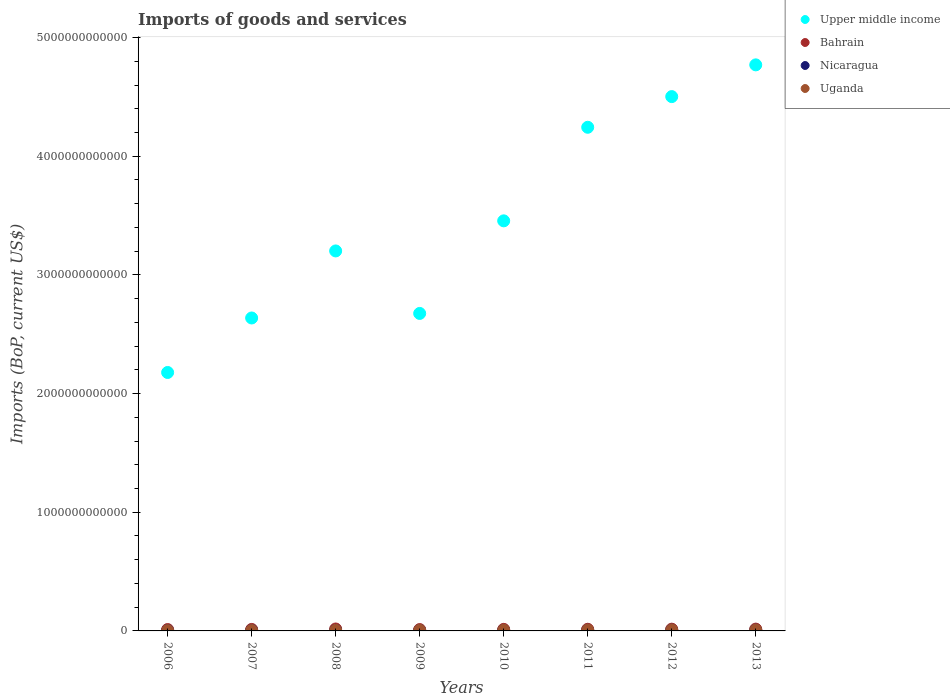How many different coloured dotlines are there?
Make the answer very short. 4. What is the amount spent on imports in Bahrain in 2010?
Keep it short and to the point. 1.31e+1. Across all years, what is the maximum amount spent on imports in Upper middle income?
Give a very brief answer. 4.77e+12. Across all years, what is the minimum amount spent on imports in Uganda?
Make the answer very short. 2.99e+09. In which year was the amount spent on imports in Bahrain maximum?
Your response must be concise. 2008. What is the total amount spent on imports in Upper middle income in the graph?
Your answer should be very brief. 2.77e+13. What is the difference between the amount spent on imports in Nicaragua in 2006 and that in 2010?
Offer a terse response. -1.38e+09. What is the difference between the amount spent on imports in Bahrain in 2009 and the amount spent on imports in Uganda in 2007?
Provide a short and direct response. 7.42e+09. What is the average amount spent on imports in Uganda per year?
Offer a very short reply. 5.80e+09. In the year 2011, what is the difference between the amount spent on imports in Upper middle income and amount spent on imports in Nicaragua?
Your answer should be compact. 4.24e+12. In how many years, is the amount spent on imports in Upper middle income greater than 3200000000000 US$?
Offer a very short reply. 5. What is the ratio of the amount spent on imports in Upper middle income in 2008 to that in 2013?
Keep it short and to the point. 0.67. Is the amount spent on imports in Nicaragua in 2007 less than that in 2010?
Keep it short and to the point. Yes. Is the difference between the amount spent on imports in Upper middle income in 2008 and 2011 greater than the difference between the amount spent on imports in Nicaragua in 2008 and 2011?
Keep it short and to the point. No. What is the difference between the highest and the second highest amount spent on imports in Uganda?
Make the answer very short. 9.31e+07. What is the difference between the highest and the lowest amount spent on imports in Nicaragua?
Offer a terse response. 3.19e+09. Does the amount spent on imports in Bahrain monotonically increase over the years?
Provide a succinct answer. No. Is the amount spent on imports in Bahrain strictly greater than the amount spent on imports in Nicaragua over the years?
Your answer should be compact. Yes. Is the amount spent on imports in Nicaragua strictly less than the amount spent on imports in Uganda over the years?
Provide a short and direct response. No. How many dotlines are there?
Your response must be concise. 4. How many years are there in the graph?
Make the answer very short. 8. What is the difference between two consecutive major ticks on the Y-axis?
Your response must be concise. 1.00e+12. Where does the legend appear in the graph?
Offer a very short reply. Top right. How many legend labels are there?
Make the answer very short. 4. How are the legend labels stacked?
Provide a short and direct response. Vertical. What is the title of the graph?
Your response must be concise. Imports of goods and services. What is the label or title of the X-axis?
Keep it short and to the point. Years. What is the label or title of the Y-axis?
Provide a short and direct response. Imports (BoP, current US$). What is the Imports (BoP, current US$) of Upper middle income in 2006?
Offer a very short reply. 2.18e+12. What is the Imports (BoP, current US$) of Bahrain in 2006?
Your response must be concise. 1.16e+1. What is the Imports (BoP, current US$) of Nicaragua in 2006?
Offer a very short reply. 3.68e+09. What is the Imports (BoP, current US$) in Uganda in 2006?
Keep it short and to the point. 2.99e+09. What is the Imports (BoP, current US$) in Upper middle income in 2007?
Provide a short and direct response. 2.64e+12. What is the Imports (BoP, current US$) of Bahrain in 2007?
Offer a terse response. 1.26e+1. What is the Imports (BoP, current US$) of Nicaragua in 2007?
Give a very brief answer. 4.45e+09. What is the Imports (BoP, current US$) in Uganda in 2007?
Your response must be concise. 3.94e+09. What is the Imports (BoP, current US$) in Upper middle income in 2008?
Provide a short and direct response. 3.20e+12. What is the Imports (BoP, current US$) of Bahrain in 2008?
Provide a succinct answer. 1.63e+1. What is the Imports (BoP, current US$) of Nicaragua in 2008?
Your response must be concise. 5.26e+09. What is the Imports (BoP, current US$) of Uganda in 2008?
Keep it short and to the point. 5.30e+09. What is the Imports (BoP, current US$) in Upper middle income in 2009?
Offer a terse response. 2.68e+12. What is the Imports (BoP, current US$) in Bahrain in 2009?
Provide a succinct answer. 1.14e+1. What is the Imports (BoP, current US$) of Nicaragua in 2009?
Provide a short and direct response. 4.41e+09. What is the Imports (BoP, current US$) in Uganda in 2009?
Offer a very short reply. 5.23e+09. What is the Imports (BoP, current US$) of Upper middle income in 2010?
Your response must be concise. 3.46e+12. What is the Imports (BoP, current US$) of Bahrain in 2010?
Offer a very short reply. 1.31e+1. What is the Imports (BoP, current US$) in Nicaragua in 2010?
Make the answer very short. 5.06e+09. What is the Imports (BoP, current US$) in Uganda in 2010?
Ensure brevity in your answer.  6.18e+09. What is the Imports (BoP, current US$) in Upper middle income in 2011?
Keep it short and to the point. 4.24e+12. What is the Imports (BoP, current US$) in Bahrain in 2011?
Your response must be concise. 1.39e+1. What is the Imports (BoP, current US$) in Nicaragua in 2011?
Give a very brief answer. 6.30e+09. What is the Imports (BoP, current US$) in Uganda in 2011?
Provide a succinct answer. 7.43e+09. What is the Imports (BoP, current US$) in Upper middle income in 2012?
Make the answer very short. 4.50e+12. What is the Imports (BoP, current US$) of Bahrain in 2012?
Give a very brief answer. 1.47e+1. What is the Imports (BoP, current US$) in Nicaragua in 2012?
Keep it short and to the point. 6.84e+09. What is the Imports (BoP, current US$) of Uganda in 2012?
Offer a terse response. 7.74e+09. What is the Imports (BoP, current US$) in Upper middle income in 2013?
Your response must be concise. 4.77e+12. What is the Imports (BoP, current US$) in Bahrain in 2013?
Provide a succinct answer. 1.52e+1. What is the Imports (BoP, current US$) of Nicaragua in 2013?
Make the answer very short. 6.87e+09. What is the Imports (BoP, current US$) of Uganda in 2013?
Your answer should be compact. 7.64e+09. Across all years, what is the maximum Imports (BoP, current US$) of Upper middle income?
Keep it short and to the point. 4.77e+12. Across all years, what is the maximum Imports (BoP, current US$) in Bahrain?
Offer a very short reply. 1.63e+1. Across all years, what is the maximum Imports (BoP, current US$) of Nicaragua?
Your response must be concise. 6.87e+09. Across all years, what is the maximum Imports (BoP, current US$) in Uganda?
Make the answer very short. 7.74e+09. Across all years, what is the minimum Imports (BoP, current US$) in Upper middle income?
Keep it short and to the point. 2.18e+12. Across all years, what is the minimum Imports (BoP, current US$) of Bahrain?
Give a very brief answer. 1.14e+1. Across all years, what is the minimum Imports (BoP, current US$) of Nicaragua?
Give a very brief answer. 3.68e+09. Across all years, what is the minimum Imports (BoP, current US$) in Uganda?
Make the answer very short. 2.99e+09. What is the total Imports (BoP, current US$) in Upper middle income in the graph?
Provide a succinct answer. 2.77e+13. What is the total Imports (BoP, current US$) of Bahrain in the graph?
Ensure brevity in your answer.  1.09e+11. What is the total Imports (BoP, current US$) of Nicaragua in the graph?
Give a very brief answer. 4.29e+1. What is the total Imports (BoP, current US$) of Uganda in the graph?
Ensure brevity in your answer.  4.64e+1. What is the difference between the Imports (BoP, current US$) in Upper middle income in 2006 and that in 2007?
Your answer should be compact. -4.59e+11. What is the difference between the Imports (BoP, current US$) of Bahrain in 2006 and that in 2007?
Offer a very short reply. -1.07e+09. What is the difference between the Imports (BoP, current US$) in Nicaragua in 2006 and that in 2007?
Make the answer very short. -7.70e+08. What is the difference between the Imports (BoP, current US$) of Uganda in 2006 and that in 2007?
Your answer should be very brief. -9.49e+08. What is the difference between the Imports (BoP, current US$) of Upper middle income in 2006 and that in 2008?
Provide a short and direct response. -1.02e+12. What is the difference between the Imports (BoP, current US$) in Bahrain in 2006 and that in 2008?
Make the answer very short. -4.72e+09. What is the difference between the Imports (BoP, current US$) in Nicaragua in 2006 and that in 2008?
Provide a short and direct response. -1.57e+09. What is the difference between the Imports (BoP, current US$) of Uganda in 2006 and that in 2008?
Offer a terse response. -2.31e+09. What is the difference between the Imports (BoP, current US$) in Upper middle income in 2006 and that in 2009?
Give a very brief answer. -4.98e+11. What is the difference between the Imports (BoP, current US$) of Bahrain in 2006 and that in 2009?
Make the answer very short. 2.05e+08. What is the difference between the Imports (BoP, current US$) of Nicaragua in 2006 and that in 2009?
Your response must be concise. -7.30e+08. What is the difference between the Imports (BoP, current US$) of Uganda in 2006 and that in 2009?
Offer a terse response. -2.24e+09. What is the difference between the Imports (BoP, current US$) in Upper middle income in 2006 and that in 2010?
Provide a succinct answer. -1.28e+12. What is the difference between the Imports (BoP, current US$) in Bahrain in 2006 and that in 2010?
Your answer should be very brief. -1.54e+09. What is the difference between the Imports (BoP, current US$) of Nicaragua in 2006 and that in 2010?
Your answer should be compact. -1.38e+09. What is the difference between the Imports (BoP, current US$) in Uganda in 2006 and that in 2010?
Your answer should be compact. -3.19e+09. What is the difference between the Imports (BoP, current US$) of Upper middle income in 2006 and that in 2011?
Make the answer very short. -2.07e+12. What is the difference between the Imports (BoP, current US$) in Bahrain in 2006 and that in 2011?
Give a very brief answer. -2.33e+09. What is the difference between the Imports (BoP, current US$) in Nicaragua in 2006 and that in 2011?
Ensure brevity in your answer.  -2.62e+09. What is the difference between the Imports (BoP, current US$) in Uganda in 2006 and that in 2011?
Offer a terse response. -4.44e+09. What is the difference between the Imports (BoP, current US$) in Upper middle income in 2006 and that in 2012?
Keep it short and to the point. -2.32e+12. What is the difference between the Imports (BoP, current US$) in Bahrain in 2006 and that in 2012?
Your answer should be very brief. -3.16e+09. What is the difference between the Imports (BoP, current US$) in Nicaragua in 2006 and that in 2012?
Your answer should be very brief. -3.16e+09. What is the difference between the Imports (BoP, current US$) of Uganda in 2006 and that in 2012?
Your response must be concise. -4.75e+09. What is the difference between the Imports (BoP, current US$) of Upper middle income in 2006 and that in 2013?
Give a very brief answer. -2.59e+12. What is the difference between the Imports (BoP, current US$) of Bahrain in 2006 and that in 2013?
Your answer should be very brief. -3.66e+09. What is the difference between the Imports (BoP, current US$) in Nicaragua in 2006 and that in 2013?
Your answer should be very brief. -3.19e+09. What is the difference between the Imports (BoP, current US$) in Uganda in 2006 and that in 2013?
Make the answer very short. -4.66e+09. What is the difference between the Imports (BoP, current US$) in Upper middle income in 2007 and that in 2008?
Ensure brevity in your answer.  -5.65e+11. What is the difference between the Imports (BoP, current US$) of Bahrain in 2007 and that in 2008?
Keep it short and to the point. -3.65e+09. What is the difference between the Imports (BoP, current US$) in Nicaragua in 2007 and that in 2008?
Your answer should be compact. -8.05e+08. What is the difference between the Imports (BoP, current US$) of Uganda in 2007 and that in 2008?
Keep it short and to the point. -1.36e+09. What is the difference between the Imports (BoP, current US$) in Upper middle income in 2007 and that in 2009?
Give a very brief answer. -3.83e+1. What is the difference between the Imports (BoP, current US$) in Bahrain in 2007 and that in 2009?
Make the answer very short. 1.27e+09. What is the difference between the Imports (BoP, current US$) of Nicaragua in 2007 and that in 2009?
Make the answer very short. 3.97e+07. What is the difference between the Imports (BoP, current US$) in Uganda in 2007 and that in 2009?
Provide a short and direct response. -1.29e+09. What is the difference between the Imports (BoP, current US$) of Upper middle income in 2007 and that in 2010?
Your response must be concise. -8.19e+11. What is the difference between the Imports (BoP, current US$) in Bahrain in 2007 and that in 2010?
Your answer should be very brief. -4.69e+08. What is the difference between the Imports (BoP, current US$) of Nicaragua in 2007 and that in 2010?
Provide a succinct answer. -6.12e+08. What is the difference between the Imports (BoP, current US$) of Uganda in 2007 and that in 2010?
Offer a terse response. -2.24e+09. What is the difference between the Imports (BoP, current US$) of Upper middle income in 2007 and that in 2011?
Provide a succinct answer. -1.61e+12. What is the difference between the Imports (BoP, current US$) in Bahrain in 2007 and that in 2011?
Provide a short and direct response. -1.26e+09. What is the difference between the Imports (BoP, current US$) of Nicaragua in 2007 and that in 2011?
Provide a succinct answer. -1.85e+09. What is the difference between the Imports (BoP, current US$) in Uganda in 2007 and that in 2011?
Ensure brevity in your answer.  -3.49e+09. What is the difference between the Imports (BoP, current US$) in Upper middle income in 2007 and that in 2012?
Give a very brief answer. -1.87e+12. What is the difference between the Imports (BoP, current US$) in Bahrain in 2007 and that in 2012?
Offer a very short reply. -2.09e+09. What is the difference between the Imports (BoP, current US$) of Nicaragua in 2007 and that in 2012?
Your answer should be very brief. -2.39e+09. What is the difference between the Imports (BoP, current US$) in Uganda in 2007 and that in 2012?
Give a very brief answer. -3.80e+09. What is the difference between the Imports (BoP, current US$) in Upper middle income in 2007 and that in 2013?
Your answer should be very brief. -2.13e+12. What is the difference between the Imports (BoP, current US$) of Bahrain in 2007 and that in 2013?
Your response must be concise. -2.59e+09. What is the difference between the Imports (BoP, current US$) of Nicaragua in 2007 and that in 2013?
Make the answer very short. -2.42e+09. What is the difference between the Imports (BoP, current US$) of Uganda in 2007 and that in 2013?
Offer a terse response. -3.71e+09. What is the difference between the Imports (BoP, current US$) in Upper middle income in 2008 and that in 2009?
Provide a short and direct response. 5.27e+11. What is the difference between the Imports (BoP, current US$) of Bahrain in 2008 and that in 2009?
Your answer should be compact. 4.92e+09. What is the difference between the Imports (BoP, current US$) of Nicaragua in 2008 and that in 2009?
Offer a terse response. 8.44e+08. What is the difference between the Imports (BoP, current US$) in Uganda in 2008 and that in 2009?
Ensure brevity in your answer.  7.20e+07. What is the difference between the Imports (BoP, current US$) in Upper middle income in 2008 and that in 2010?
Your answer should be very brief. -2.54e+11. What is the difference between the Imports (BoP, current US$) of Bahrain in 2008 and that in 2010?
Make the answer very short. 3.18e+09. What is the difference between the Imports (BoP, current US$) of Nicaragua in 2008 and that in 2010?
Your answer should be very brief. 1.92e+08. What is the difference between the Imports (BoP, current US$) in Uganda in 2008 and that in 2010?
Provide a short and direct response. -8.78e+08. What is the difference between the Imports (BoP, current US$) of Upper middle income in 2008 and that in 2011?
Provide a short and direct response. -1.04e+12. What is the difference between the Imports (BoP, current US$) of Bahrain in 2008 and that in 2011?
Give a very brief answer. 2.39e+09. What is the difference between the Imports (BoP, current US$) of Nicaragua in 2008 and that in 2011?
Offer a very short reply. -1.05e+09. What is the difference between the Imports (BoP, current US$) in Uganda in 2008 and that in 2011?
Ensure brevity in your answer.  -2.13e+09. What is the difference between the Imports (BoP, current US$) in Upper middle income in 2008 and that in 2012?
Provide a short and direct response. -1.30e+12. What is the difference between the Imports (BoP, current US$) of Bahrain in 2008 and that in 2012?
Your response must be concise. 1.56e+09. What is the difference between the Imports (BoP, current US$) in Nicaragua in 2008 and that in 2012?
Provide a succinct answer. -1.58e+09. What is the difference between the Imports (BoP, current US$) in Uganda in 2008 and that in 2012?
Offer a terse response. -2.44e+09. What is the difference between the Imports (BoP, current US$) of Upper middle income in 2008 and that in 2013?
Your answer should be very brief. -1.57e+12. What is the difference between the Imports (BoP, current US$) in Bahrain in 2008 and that in 2013?
Your answer should be compact. 1.06e+09. What is the difference between the Imports (BoP, current US$) in Nicaragua in 2008 and that in 2013?
Provide a succinct answer. -1.62e+09. What is the difference between the Imports (BoP, current US$) in Uganda in 2008 and that in 2013?
Offer a terse response. -2.34e+09. What is the difference between the Imports (BoP, current US$) of Upper middle income in 2009 and that in 2010?
Make the answer very short. -7.80e+11. What is the difference between the Imports (BoP, current US$) in Bahrain in 2009 and that in 2010?
Your answer should be compact. -1.74e+09. What is the difference between the Imports (BoP, current US$) of Nicaragua in 2009 and that in 2010?
Offer a very short reply. -6.52e+08. What is the difference between the Imports (BoP, current US$) of Uganda in 2009 and that in 2010?
Offer a terse response. -9.50e+08. What is the difference between the Imports (BoP, current US$) in Upper middle income in 2009 and that in 2011?
Provide a succinct answer. -1.57e+12. What is the difference between the Imports (BoP, current US$) of Bahrain in 2009 and that in 2011?
Your response must be concise. -2.53e+09. What is the difference between the Imports (BoP, current US$) in Nicaragua in 2009 and that in 2011?
Your answer should be compact. -1.89e+09. What is the difference between the Imports (BoP, current US$) of Uganda in 2009 and that in 2011?
Ensure brevity in your answer.  -2.20e+09. What is the difference between the Imports (BoP, current US$) in Upper middle income in 2009 and that in 2012?
Keep it short and to the point. -1.83e+12. What is the difference between the Imports (BoP, current US$) in Bahrain in 2009 and that in 2012?
Your response must be concise. -3.37e+09. What is the difference between the Imports (BoP, current US$) in Nicaragua in 2009 and that in 2012?
Ensure brevity in your answer.  -2.43e+09. What is the difference between the Imports (BoP, current US$) of Uganda in 2009 and that in 2012?
Your answer should be very brief. -2.51e+09. What is the difference between the Imports (BoP, current US$) of Upper middle income in 2009 and that in 2013?
Your response must be concise. -2.09e+12. What is the difference between the Imports (BoP, current US$) of Bahrain in 2009 and that in 2013?
Your answer should be very brief. -3.86e+09. What is the difference between the Imports (BoP, current US$) in Nicaragua in 2009 and that in 2013?
Offer a terse response. -2.46e+09. What is the difference between the Imports (BoP, current US$) in Uganda in 2009 and that in 2013?
Make the answer very short. -2.41e+09. What is the difference between the Imports (BoP, current US$) of Upper middle income in 2010 and that in 2011?
Give a very brief answer. -7.88e+11. What is the difference between the Imports (BoP, current US$) of Bahrain in 2010 and that in 2011?
Make the answer very short. -7.89e+08. What is the difference between the Imports (BoP, current US$) of Nicaragua in 2010 and that in 2011?
Offer a very short reply. -1.24e+09. What is the difference between the Imports (BoP, current US$) of Uganda in 2010 and that in 2011?
Provide a succinct answer. -1.25e+09. What is the difference between the Imports (BoP, current US$) in Upper middle income in 2010 and that in 2012?
Keep it short and to the point. -1.05e+12. What is the difference between the Imports (BoP, current US$) in Bahrain in 2010 and that in 2012?
Your response must be concise. -1.62e+09. What is the difference between the Imports (BoP, current US$) in Nicaragua in 2010 and that in 2012?
Offer a very short reply. -1.77e+09. What is the difference between the Imports (BoP, current US$) in Uganda in 2010 and that in 2012?
Keep it short and to the point. -1.56e+09. What is the difference between the Imports (BoP, current US$) in Upper middle income in 2010 and that in 2013?
Provide a succinct answer. -1.31e+12. What is the difference between the Imports (BoP, current US$) of Bahrain in 2010 and that in 2013?
Your answer should be compact. -2.12e+09. What is the difference between the Imports (BoP, current US$) of Nicaragua in 2010 and that in 2013?
Keep it short and to the point. -1.81e+09. What is the difference between the Imports (BoP, current US$) in Uganda in 2010 and that in 2013?
Give a very brief answer. -1.46e+09. What is the difference between the Imports (BoP, current US$) of Upper middle income in 2011 and that in 2012?
Ensure brevity in your answer.  -2.58e+11. What is the difference between the Imports (BoP, current US$) in Bahrain in 2011 and that in 2012?
Give a very brief answer. -8.35e+08. What is the difference between the Imports (BoP, current US$) in Nicaragua in 2011 and that in 2012?
Make the answer very short. -5.32e+08. What is the difference between the Imports (BoP, current US$) of Uganda in 2011 and that in 2012?
Your answer should be very brief. -3.05e+08. What is the difference between the Imports (BoP, current US$) in Upper middle income in 2011 and that in 2013?
Offer a very short reply. -5.26e+11. What is the difference between the Imports (BoP, current US$) in Bahrain in 2011 and that in 2013?
Your answer should be very brief. -1.33e+09. What is the difference between the Imports (BoP, current US$) in Nicaragua in 2011 and that in 2013?
Provide a succinct answer. -5.68e+08. What is the difference between the Imports (BoP, current US$) of Uganda in 2011 and that in 2013?
Offer a terse response. -2.12e+08. What is the difference between the Imports (BoP, current US$) in Upper middle income in 2012 and that in 2013?
Make the answer very short. -2.68e+11. What is the difference between the Imports (BoP, current US$) in Bahrain in 2012 and that in 2013?
Make the answer very short. -4.97e+08. What is the difference between the Imports (BoP, current US$) in Nicaragua in 2012 and that in 2013?
Ensure brevity in your answer.  -3.58e+07. What is the difference between the Imports (BoP, current US$) of Uganda in 2012 and that in 2013?
Offer a very short reply. 9.31e+07. What is the difference between the Imports (BoP, current US$) of Upper middle income in 2006 and the Imports (BoP, current US$) of Bahrain in 2007?
Your answer should be very brief. 2.17e+12. What is the difference between the Imports (BoP, current US$) of Upper middle income in 2006 and the Imports (BoP, current US$) of Nicaragua in 2007?
Ensure brevity in your answer.  2.17e+12. What is the difference between the Imports (BoP, current US$) in Upper middle income in 2006 and the Imports (BoP, current US$) in Uganda in 2007?
Your answer should be compact. 2.17e+12. What is the difference between the Imports (BoP, current US$) in Bahrain in 2006 and the Imports (BoP, current US$) in Nicaragua in 2007?
Your response must be concise. 7.11e+09. What is the difference between the Imports (BoP, current US$) in Bahrain in 2006 and the Imports (BoP, current US$) in Uganda in 2007?
Keep it short and to the point. 7.62e+09. What is the difference between the Imports (BoP, current US$) of Nicaragua in 2006 and the Imports (BoP, current US$) of Uganda in 2007?
Offer a very short reply. -2.55e+08. What is the difference between the Imports (BoP, current US$) of Upper middle income in 2006 and the Imports (BoP, current US$) of Bahrain in 2008?
Your answer should be very brief. 2.16e+12. What is the difference between the Imports (BoP, current US$) of Upper middle income in 2006 and the Imports (BoP, current US$) of Nicaragua in 2008?
Ensure brevity in your answer.  2.17e+12. What is the difference between the Imports (BoP, current US$) of Upper middle income in 2006 and the Imports (BoP, current US$) of Uganda in 2008?
Keep it short and to the point. 2.17e+12. What is the difference between the Imports (BoP, current US$) of Bahrain in 2006 and the Imports (BoP, current US$) of Nicaragua in 2008?
Make the answer very short. 6.30e+09. What is the difference between the Imports (BoP, current US$) of Bahrain in 2006 and the Imports (BoP, current US$) of Uganda in 2008?
Your answer should be very brief. 6.26e+09. What is the difference between the Imports (BoP, current US$) in Nicaragua in 2006 and the Imports (BoP, current US$) in Uganda in 2008?
Keep it short and to the point. -1.62e+09. What is the difference between the Imports (BoP, current US$) in Upper middle income in 2006 and the Imports (BoP, current US$) in Bahrain in 2009?
Ensure brevity in your answer.  2.17e+12. What is the difference between the Imports (BoP, current US$) of Upper middle income in 2006 and the Imports (BoP, current US$) of Nicaragua in 2009?
Keep it short and to the point. 2.17e+12. What is the difference between the Imports (BoP, current US$) of Upper middle income in 2006 and the Imports (BoP, current US$) of Uganda in 2009?
Make the answer very short. 2.17e+12. What is the difference between the Imports (BoP, current US$) in Bahrain in 2006 and the Imports (BoP, current US$) in Nicaragua in 2009?
Give a very brief answer. 7.15e+09. What is the difference between the Imports (BoP, current US$) of Bahrain in 2006 and the Imports (BoP, current US$) of Uganda in 2009?
Your answer should be compact. 6.33e+09. What is the difference between the Imports (BoP, current US$) in Nicaragua in 2006 and the Imports (BoP, current US$) in Uganda in 2009?
Your response must be concise. -1.55e+09. What is the difference between the Imports (BoP, current US$) in Upper middle income in 2006 and the Imports (BoP, current US$) in Bahrain in 2010?
Offer a terse response. 2.16e+12. What is the difference between the Imports (BoP, current US$) in Upper middle income in 2006 and the Imports (BoP, current US$) in Nicaragua in 2010?
Your answer should be compact. 2.17e+12. What is the difference between the Imports (BoP, current US$) of Upper middle income in 2006 and the Imports (BoP, current US$) of Uganda in 2010?
Provide a short and direct response. 2.17e+12. What is the difference between the Imports (BoP, current US$) of Bahrain in 2006 and the Imports (BoP, current US$) of Nicaragua in 2010?
Keep it short and to the point. 6.50e+09. What is the difference between the Imports (BoP, current US$) of Bahrain in 2006 and the Imports (BoP, current US$) of Uganda in 2010?
Make the answer very short. 5.38e+09. What is the difference between the Imports (BoP, current US$) in Nicaragua in 2006 and the Imports (BoP, current US$) in Uganda in 2010?
Your answer should be compact. -2.50e+09. What is the difference between the Imports (BoP, current US$) in Upper middle income in 2006 and the Imports (BoP, current US$) in Bahrain in 2011?
Provide a short and direct response. 2.16e+12. What is the difference between the Imports (BoP, current US$) in Upper middle income in 2006 and the Imports (BoP, current US$) in Nicaragua in 2011?
Offer a very short reply. 2.17e+12. What is the difference between the Imports (BoP, current US$) of Upper middle income in 2006 and the Imports (BoP, current US$) of Uganda in 2011?
Your answer should be very brief. 2.17e+12. What is the difference between the Imports (BoP, current US$) in Bahrain in 2006 and the Imports (BoP, current US$) in Nicaragua in 2011?
Your answer should be compact. 5.25e+09. What is the difference between the Imports (BoP, current US$) of Bahrain in 2006 and the Imports (BoP, current US$) of Uganda in 2011?
Provide a succinct answer. 4.13e+09. What is the difference between the Imports (BoP, current US$) of Nicaragua in 2006 and the Imports (BoP, current US$) of Uganda in 2011?
Your answer should be compact. -3.75e+09. What is the difference between the Imports (BoP, current US$) in Upper middle income in 2006 and the Imports (BoP, current US$) in Bahrain in 2012?
Ensure brevity in your answer.  2.16e+12. What is the difference between the Imports (BoP, current US$) of Upper middle income in 2006 and the Imports (BoP, current US$) of Nicaragua in 2012?
Your answer should be compact. 2.17e+12. What is the difference between the Imports (BoP, current US$) of Upper middle income in 2006 and the Imports (BoP, current US$) of Uganda in 2012?
Provide a succinct answer. 2.17e+12. What is the difference between the Imports (BoP, current US$) of Bahrain in 2006 and the Imports (BoP, current US$) of Nicaragua in 2012?
Offer a very short reply. 4.72e+09. What is the difference between the Imports (BoP, current US$) in Bahrain in 2006 and the Imports (BoP, current US$) in Uganda in 2012?
Your answer should be compact. 3.82e+09. What is the difference between the Imports (BoP, current US$) in Nicaragua in 2006 and the Imports (BoP, current US$) in Uganda in 2012?
Your answer should be very brief. -4.05e+09. What is the difference between the Imports (BoP, current US$) of Upper middle income in 2006 and the Imports (BoP, current US$) of Bahrain in 2013?
Offer a terse response. 2.16e+12. What is the difference between the Imports (BoP, current US$) of Upper middle income in 2006 and the Imports (BoP, current US$) of Nicaragua in 2013?
Ensure brevity in your answer.  2.17e+12. What is the difference between the Imports (BoP, current US$) in Upper middle income in 2006 and the Imports (BoP, current US$) in Uganda in 2013?
Keep it short and to the point. 2.17e+12. What is the difference between the Imports (BoP, current US$) of Bahrain in 2006 and the Imports (BoP, current US$) of Nicaragua in 2013?
Your answer should be very brief. 4.69e+09. What is the difference between the Imports (BoP, current US$) of Bahrain in 2006 and the Imports (BoP, current US$) of Uganda in 2013?
Offer a terse response. 3.92e+09. What is the difference between the Imports (BoP, current US$) in Nicaragua in 2006 and the Imports (BoP, current US$) in Uganda in 2013?
Keep it short and to the point. -3.96e+09. What is the difference between the Imports (BoP, current US$) of Upper middle income in 2007 and the Imports (BoP, current US$) of Bahrain in 2008?
Provide a succinct answer. 2.62e+12. What is the difference between the Imports (BoP, current US$) of Upper middle income in 2007 and the Imports (BoP, current US$) of Nicaragua in 2008?
Ensure brevity in your answer.  2.63e+12. What is the difference between the Imports (BoP, current US$) in Upper middle income in 2007 and the Imports (BoP, current US$) in Uganda in 2008?
Make the answer very short. 2.63e+12. What is the difference between the Imports (BoP, current US$) of Bahrain in 2007 and the Imports (BoP, current US$) of Nicaragua in 2008?
Provide a succinct answer. 7.37e+09. What is the difference between the Imports (BoP, current US$) in Bahrain in 2007 and the Imports (BoP, current US$) in Uganda in 2008?
Your response must be concise. 7.33e+09. What is the difference between the Imports (BoP, current US$) in Nicaragua in 2007 and the Imports (BoP, current US$) in Uganda in 2008?
Keep it short and to the point. -8.49e+08. What is the difference between the Imports (BoP, current US$) of Upper middle income in 2007 and the Imports (BoP, current US$) of Bahrain in 2009?
Offer a terse response. 2.63e+12. What is the difference between the Imports (BoP, current US$) of Upper middle income in 2007 and the Imports (BoP, current US$) of Nicaragua in 2009?
Your response must be concise. 2.63e+12. What is the difference between the Imports (BoP, current US$) in Upper middle income in 2007 and the Imports (BoP, current US$) in Uganda in 2009?
Keep it short and to the point. 2.63e+12. What is the difference between the Imports (BoP, current US$) of Bahrain in 2007 and the Imports (BoP, current US$) of Nicaragua in 2009?
Provide a succinct answer. 8.22e+09. What is the difference between the Imports (BoP, current US$) of Bahrain in 2007 and the Imports (BoP, current US$) of Uganda in 2009?
Your answer should be compact. 7.40e+09. What is the difference between the Imports (BoP, current US$) of Nicaragua in 2007 and the Imports (BoP, current US$) of Uganda in 2009?
Provide a succinct answer. -7.77e+08. What is the difference between the Imports (BoP, current US$) in Upper middle income in 2007 and the Imports (BoP, current US$) in Bahrain in 2010?
Provide a succinct answer. 2.62e+12. What is the difference between the Imports (BoP, current US$) of Upper middle income in 2007 and the Imports (BoP, current US$) of Nicaragua in 2010?
Offer a very short reply. 2.63e+12. What is the difference between the Imports (BoP, current US$) of Upper middle income in 2007 and the Imports (BoP, current US$) of Uganda in 2010?
Your answer should be compact. 2.63e+12. What is the difference between the Imports (BoP, current US$) in Bahrain in 2007 and the Imports (BoP, current US$) in Nicaragua in 2010?
Your response must be concise. 7.56e+09. What is the difference between the Imports (BoP, current US$) of Bahrain in 2007 and the Imports (BoP, current US$) of Uganda in 2010?
Keep it short and to the point. 6.45e+09. What is the difference between the Imports (BoP, current US$) in Nicaragua in 2007 and the Imports (BoP, current US$) in Uganda in 2010?
Give a very brief answer. -1.73e+09. What is the difference between the Imports (BoP, current US$) in Upper middle income in 2007 and the Imports (BoP, current US$) in Bahrain in 2011?
Ensure brevity in your answer.  2.62e+12. What is the difference between the Imports (BoP, current US$) of Upper middle income in 2007 and the Imports (BoP, current US$) of Nicaragua in 2011?
Your answer should be compact. 2.63e+12. What is the difference between the Imports (BoP, current US$) in Upper middle income in 2007 and the Imports (BoP, current US$) in Uganda in 2011?
Provide a short and direct response. 2.63e+12. What is the difference between the Imports (BoP, current US$) in Bahrain in 2007 and the Imports (BoP, current US$) in Nicaragua in 2011?
Your answer should be compact. 6.32e+09. What is the difference between the Imports (BoP, current US$) in Bahrain in 2007 and the Imports (BoP, current US$) in Uganda in 2011?
Provide a short and direct response. 5.20e+09. What is the difference between the Imports (BoP, current US$) in Nicaragua in 2007 and the Imports (BoP, current US$) in Uganda in 2011?
Provide a succinct answer. -2.98e+09. What is the difference between the Imports (BoP, current US$) in Upper middle income in 2007 and the Imports (BoP, current US$) in Bahrain in 2012?
Your response must be concise. 2.62e+12. What is the difference between the Imports (BoP, current US$) in Upper middle income in 2007 and the Imports (BoP, current US$) in Nicaragua in 2012?
Your response must be concise. 2.63e+12. What is the difference between the Imports (BoP, current US$) of Upper middle income in 2007 and the Imports (BoP, current US$) of Uganda in 2012?
Your answer should be compact. 2.63e+12. What is the difference between the Imports (BoP, current US$) in Bahrain in 2007 and the Imports (BoP, current US$) in Nicaragua in 2012?
Provide a short and direct response. 5.79e+09. What is the difference between the Imports (BoP, current US$) in Bahrain in 2007 and the Imports (BoP, current US$) in Uganda in 2012?
Your answer should be very brief. 4.89e+09. What is the difference between the Imports (BoP, current US$) in Nicaragua in 2007 and the Imports (BoP, current US$) in Uganda in 2012?
Provide a succinct answer. -3.28e+09. What is the difference between the Imports (BoP, current US$) of Upper middle income in 2007 and the Imports (BoP, current US$) of Bahrain in 2013?
Offer a terse response. 2.62e+12. What is the difference between the Imports (BoP, current US$) in Upper middle income in 2007 and the Imports (BoP, current US$) in Nicaragua in 2013?
Your answer should be compact. 2.63e+12. What is the difference between the Imports (BoP, current US$) of Upper middle income in 2007 and the Imports (BoP, current US$) of Uganda in 2013?
Provide a succinct answer. 2.63e+12. What is the difference between the Imports (BoP, current US$) in Bahrain in 2007 and the Imports (BoP, current US$) in Nicaragua in 2013?
Make the answer very short. 5.75e+09. What is the difference between the Imports (BoP, current US$) in Bahrain in 2007 and the Imports (BoP, current US$) in Uganda in 2013?
Offer a very short reply. 4.98e+09. What is the difference between the Imports (BoP, current US$) of Nicaragua in 2007 and the Imports (BoP, current US$) of Uganda in 2013?
Your response must be concise. -3.19e+09. What is the difference between the Imports (BoP, current US$) of Upper middle income in 2008 and the Imports (BoP, current US$) of Bahrain in 2009?
Provide a short and direct response. 3.19e+12. What is the difference between the Imports (BoP, current US$) of Upper middle income in 2008 and the Imports (BoP, current US$) of Nicaragua in 2009?
Keep it short and to the point. 3.20e+12. What is the difference between the Imports (BoP, current US$) of Upper middle income in 2008 and the Imports (BoP, current US$) of Uganda in 2009?
Offer a very short reply. 3.20e+12. What is the difference between the Imports (BoP, current US$) of Bahrain in 2008 and the Imports (BoP, current US$) of Nicaragua in 2009?
Keep it short and to the point. 1.19e+1. What is the difference between the Imports (BoP, current US$) in Bahrain in 2008 and the Imports (BoP, current US$) in Uganda in 2009?
Make the answer very short. 1.10e+1. What is the difference between the Imports (BoP, current US$) of Nicaragua in 2008 and the Imports (BoP, current US$) of Uganda in 2009?
Offer a very short reply. 2.71e+07. What is the difference between the Imports (BoP, current US$) of Upper middle income in 2008 and the Imports (BoP, current US$) of Bahrain in 2010?
Keep it short and to the point. 3.19e+12. What is the difference between the Imports (BoP, current US$) of Upper middle income in 2008 and the Imports (BoP, current US$) of Nicaragua in 2010?
Your answer should be compact. 3.20e+12. What is the difference between the Imports (BoP, current US$) in Upper middle income in 2008 and the Imports (BoP, current US$) in Uganda in 2010?
Give a very brief answer. 3.20e+12. What is the difference between the Imports (BoP, current US$) in Bahrain in 2008 and the Imports (BoP, current US$) in Nicaragua in 2010?
Your response must be concise. 1.12e+1. What is the difference between the Imports (BoP, current US$) in Bahrain in 2008 and the Imports (BoP, current US$) in Uganda in 2010?
Offer a terse response. 1.01e+1. What is the difference between the Imports (BoP, current US$) in Nicaragua in 2008 and the Imports (BoP, current US$) in Uganda in 2010?
Offer a very short reply. -9.23e+08. What is the difference between the Imports (BoP, current US$) in Upper middle income in 2008 and the Imports (BoP, current US$) in Bahrain in 2011?
Your response must be concise. 3.19e+12. What is the difference between the Imports (BoP, current US$) in Upper middle income in 2008 and the Imports (BoP, current US$) in Nicaragua in 2011?
Your answer should be very brief. 3.20e+12. What is the difference between the Imports (BoP, current US$) in Upper middle income in 2008 and the Imports (BoP, current US$) in Uganda in 2011?
Your response must be concise. 3.19e+12. What is the difference between the Imports (BoP, current US$) in Bahrain in 2008 and the Imports (BoP, current US$) in Nicaragua in 2011?
Keep it short and to the point. 9.97e+09. What is the difference between the Imports (BoP, current US$) of Bahrain in 2008 and the Imports (BoP, current US$) of Uganda in 2011?
Make the answer very short. 8.85e+09. What is the difference between the Imports (BoP, current US$) of Nicaragua in 2008 and the Imports (BoP, current US$) of Uganda in 2011?
Your answer should be compact. -2.18e+09. What is the difference between the Imports (BoP, current US$) of Upper middle income in 2008 and the Imports (BoP, current US$) of Bahrain in 2012?
Provide a short and direct response. 3.19e+12. What is the difference between the Imports (BoP, current US$) in Upper middle income in 2008 and the Imports (BoP, current US$) in Nicaragua in 2012?
Your response must be concise. 3.20e+12. What is the difference between the Imports (BoP, current US$) of Upper middle income in 2008 and the Imports (BoP, current US$) of Uganda in 2012?
Ensure brevity in your answer.  3.19e+12. What is the difference between the Imports (BoP, current US$) of Bahrain in 2008 and the Imports (BoP, current US$) of Nicaragua in 2012?
Your answer should be compact. 9.44e+09. What is the difference between the Imports (BoP, current US$) in Bahrain in 2008 and the Imports (BoP, current US$) in Uganda in 2012?
Keep it short and to the point. 8.54e+09. What is the difference between the Imports (BoP, current US$) of Nicaragua in 2008 and the Imports (BoP, current US$) of Uganda in 2012?
Offer a terse response. -2.48e+09. What is the difference between the Imports (BoP, current US$) in Upper middle income in 2008 and the Imports (BoP, current US$) in Bahrain in 2013?
Offer a very short reply. 3.19e+12. What is the difference between the Imports (BoP, current US$) in Upper middle income in 2008 and the Imports (BoP, current US$) in Nicaragua in 2013?
Give a very brief answer. 3.20e+12. What is the difference between the Imports (BoP, current US$) of Upper middle income in 2008 and the Imports (BoP, current US$) of Uganda in 2013?
Give a very brief answer. 3.19e+12. What is the difference between the Imports (BoP, current US$) in Bahrain in 2008 and the Imports (BoP, current US$) in Nicaragua in 2013?
Offer a very short reply. 9.40e+09. What is the difference between the Imports (BoP, current US$) of Bahrain in 2008 and the Imports (BoP, current US$) of Uganda in 2013?
Make the answer very short. 8.63e+09. What is the difference between the Imports (BoP, current US$) in Nicaragua in 2008 and the Imports (BoP, current US$) in Uganda in 2013?
Give a very brief answer. -2.39e+09. What is the difference between the Imports (BoP, current US$) in Upper middle income in 2009 and the Imports (BoP, current US$) in Bahrain in 2010?
Offer a terse response. 2.66e+12. What is the difference between the Imports (BoP, current US$) of Upper middle income in 2009 and the Imports (BoP, current US$) of Nicaragua in 2010?
Make the answer very short. 2.67e+12. What is the difference between the Imports (BoP, current US$) of Upper middle income in 2009 and the Imports (BoP, current US$) of Uganda in 2010?
Ensure brevity in your answer.  2.67e+12. What is the difference between the Imports (BoP, current US$) in Bahrain in 2009 and the Imports (BoP, current US$) in Nicaragua in 2010?
Your response must be concise. 6.29e+09. What is the difference between the Imports (BoP, current US$) of Bahrain in 2009 and the Imports (BoP, current US$) of Uganda in 2010?
Provide a succinct answer. 5.18e+09. What is the difference between the Imports (BoP, current US$) of Nicaragua in 2009 and the Imports (BoP, current US$) of Uganda in 2010?
Keep it short and to the point. -1.77e+09. What is the difference between the Imports (BoP, current US$) of Upper middle income in 2009 and the Imports (BoP, current US$) of Bahrain in 2011?
Keep it short and to the point. 2.66e+12. What is the difference between the Imports (BoP, current US$) in Upper middle income in 2009 and the Imports (BoP, current US$) in Nicaragua in 2011?
Offer a very short reply. 2.67e+12. What is the difference between the Imports (BoP, current US$) of Upper middle income in 2009 and the Imports (BoP, current US$) of Uganda in 2011?
Provide a short and direct response. 2.67e+12. What is the difference between the Imports (BoP, current US$) of Bahrain in 2009 and the Imports (BoP, current US$) of Nicaragua in 2011?
Offer a very short reply. 5.05e+09. What is the difference between the Imports (BoP, current US$) of Bahrain in 2009 and the Imports (BoP, current US$) of Uganda in 2011?
Provide a short and direct response. 3.92e+09. What is the difference between the Imports (BoP, current US$) of Nicaragua in 2009 and the Imports (BoP, current US$) of Uganda in 2011?
Offer a very short reply. -3.02e+09. What is the difference between the Imports (BoP, current US$) in Upper middle income in 2009 and the Imports (BoP, current US$) in Bahrain in 2012?
Keep it short and to the point. 2.66e+12. What is the difference between the Imports (BoP, current US$) of Upper middle income in 2009 and the Imports (BoP, current US$) of Nicaragua in 2012?
Keep it short and to the point. 2.67e+12. What is the difference between the Imports (BoP, current US$) in Upper middle income in 2009 and the Imports (BoP, current US$) in Uganda in 2012?
Provide a short and direct response. 2.67e+12. What is the difference between the Imports (BoP, current US$) of Bahrain in 2009 and the Imports (BoP, current US$) of Nicaragua in 2012?
Your response must be concise. 4.52e+09. What is the difference between the Imports (BoP, current US$) in Bahrain in 2009 and the Imports (BoP, current US$) in Uganda in 2012?
Offer a terse response. 3.62e+09. What is the difference between the Imports (BoP, current US$) in Nicaragua in 2009 and the Imports (BoP, current US$) in Uganda in 2012?
Ensure brevity in your answer.  -3.32e+09. What is the difference between the Imports (BoP, current US$) of Upper middle income in 2009 and the Imports (BoP, current US$) of Bahrain in 2013?
Your answer should be compact. 2.66e+12. What is the difference between the Imports (BoP, current US$) of Upper middle income in 2009 and the Imports (BoP, current US$) of Nicaragua in 2013?
Keep it short and to the point. 2.67e+12. What is the difference between the Imports (BoP, current US$) of Upper middle income in 2009 and the Imports (BoP, current US$) of Uganda in 2013?
Your answer should be compact. 2.67e+12. What is the difference between the Imports (BoP, current US$) of Bahrain in 2009 and the Imports (BoP, current US$) of Nicaragua in 2013?
Your answer should be very brief. 4.48e+09. What is the difference between the Imports (BoP, current US$) in Bahrain in 2009 and the Imports (BoP, current US$) in Uganda in 2013?
Offer a terse response. 3.71e+09. What is the difference between the Imports (BoP, current US$) of Nicaragua in 2009 and the Imports (BoP, current US$) of Uganda in 2013?
Make the answer very short. -3.23e+09. What is the difference between the Imports (BoP, current US$) in Upper middle income in 2010 and the Imports (BoP, current US$) in Bahrain in 2011?
Provide a short and direct response. 3.44e+12. What is the difference between the Imports (BoP, current US$) of Upper middle income in 2010 and the Imports (BoP, current US$) of Nicaragua in 2011?
Provide a short and direct response. 3.45e+12. What is the difference between the Imports (BoP, current US$) in Upper middle income in 2010 and the Imports (BoP, current US$) in Uganda in 2011?
Give a very brief answer. 3.45e+12. What is the difference between the Imports (BoP, current US$) of Bahrain in 2010 and the Imports (BoP, current US$) of Nicaragua in 2011?
Provide a succinct answer. 6.79e+09. What is the difference between the Imports (BoP, current US$) of Bahrain in 2010 and the Imports (BoP, current US$) of Uganda in 2011?
Make the answer very short. 5.67e+09. What is the difference between the Imports (BoP, current US$) of Nicaragua in 2010 and the Imports (BoP, current US$) of Uganda in 2011?
Provide a short and direct response. -2.37e+09. What is the difference between the Imports (BoP, current US$) of Upper middle income in 2010 and the Imports (BoP, current US$) of Bahrain in 2012?
Provide a succinct answer. 3.44e+12. What is the difference between the Imports (BoP, current US$) of Upper middle income in 2010 and the Imports (BoP, current US$) of Nicaragua in 2012?
Your answer should be very brief. 3.45e+12. What is the difference between the Imports (BoP, current US$) in Upper middle income in 2010 and the Imports (BoP, current US$) in Uganda in 2012?
Offer a very short reply. 3.45e+12. What is the difference between the Imports (BoP, current US$) of Bahrain in 2010 and the Imports (BoP, current US$) of Nicaragua in 2012?
Give a very brief answer. 6.26e+09. What is the difference between the Imports (BoP, current US$) in Bahrain in 2010 and the Imports (BoP, current US$) in Uganda in 2012?
Your answer should be compact. 5.36e+09. What is the difference between the Imports (BoP, current US$) of Nicaragua in 2010 and the Imports (BoP, current US$) of Uganda in 2012?
Ensure brevity in your answer.  -2.67e+09. What is the difference between the Imports (BoP, current US$) of Upper middle income in 2010 and the Imports (BoP, current US$) of Bahrain in 2013?
Provide a short and direct response. 3.44e+12. What is the difference between the Imports (BoP, current US$) of Upper middle income in 2010 and the Imports (BoP, current US$) of Nicaragua in 2013?
Offer a terse response. 3.45e+12. What is the difference between the Imports (BoP, current US$) in Upper middle income in 2010 and the Imports (BoP, current US$) in Uganda in 2013?
Your answer should be compact. 3.45e+12. What is the difference between the Imports (BoP, current US$) of Bahrain in 2010 and the Imports (BoP, current US$) of Nicaragua in 2013?
Your response must be concise. 6.22e+09. What is the difference between the Imports (BoP, current US$) of Bahrain in 2010 and the Imports (BoP, current US$) of Uganda in 2013?
Offer a very short reply. 5.45e+09. What is the difference between the Imports (BoP, current US$) of Nicaragua in 2010 and the Imports (BoP, current US$) of Uganda in 2013?
Ensure brevity in your answer.  -2.58e+09. What is the difference between the Imports (BoP, current US$) of Upper middle income in 2011 and the Imports (BoP, current US$) of Bahrain in 2012?
Provide a short and direct response. 4.23e+12. What is the difference between the Imports (BoP, current US$) in Upper middle income in 2011 and the Imports (BoP, current US$) in Nicaragua in 2012?
Give a very brief answer. 4.24e+12. What is the difference between the Imports (BoP, current US$) in Upper middle income in 2011 and the Imports (BoP, current US$) in Uganda in 2012?
Make the answer very short. 4.24e+12. What is the difference between the Imports (BoP, current US$) of Bahrain in 2011 and the Imports (BoP, current US$) of Nicaragua in 2012?
Your response must be concise. 7.05e+09. What is the difference between the Imports (BoP, current US$) in Bahrain in 2011 and the Imports (BoP, current US$) in Uganda in 2012?
Your response must be concise. 6.15e+09. What is the difference between the Imports (BoP, current US$) of Nicaragua in 2011 and the Imports (BoP, current US$) of Uganda in 2012?
Provide a short and direct response. -1.43e+09. What is the difference between the Imports (BoP, current US$) in Upper middle income in 2011 and the Imports (BoP, current US$) in Bahrain in 2013?
Make the answer very short. 4.23e+12. What is the difference between the Imports (BoP, current US$) of Upper middle income in 2011 and the Imports (BoP, current US$) of Nicaragua in 2013?
Make the answer very short. 4.24e+12. What is the difference between the Imports (BoP, current US$) of Upper middle income in 2011 and the Imports (BoP, current US$) of Uganda in 2013?
Give a very brief answer. 4.24e+12. What is the difference between the Imports (BoP, current US$) in Bahrain in 2011 and the Imports (BoP, current US$) in Nicaragua in 2013?
Make the answer very short. 7.01e+09. What is the difference between the Imports (BoP, current US$) of Bahrain in 2011 and the Imports (BoP, current US$) of Uganda in 2013?
Your answer should be very brief. 6.24e+09. What is the difference between the Imports (BoP, current US$) of Nicaragua in 2011 and the Imports (BoP, current US$) of Uganda in 2013?
Ensure brevity in your answer.  -1.34e+09. What is the difference between the Imports (BoP, current US$) in Upper middle income in 2012 and the Imports (BoP, current US$) in Bahrain in 2013?
Keep it short and to the point. 4.49e+12. What is the difference between the Imports (BoP, current US$) of Upper middle income in 2012 and the Imports (BoP, current US$) of Nicaragua in 2013?
Make the answer very short. 4.50e+12. What is the difference between the Imports (BoP, current US$) of Upper middle income in 2012 and the Imports (BoP, current US$) of Uganda in 2013?
Keep it short and to the point. 4.49e+12. What is the difference between the Imports (BoP, current US$) in Bahrain in 2012 and the Imports (BoP, current US$) in Nicaragua in 2013?
Offer a very short reply. 7.85e+09. What is the difference between the Imports (BoP, current US$) in Bahrain in 2012 and the Imports (BoP, current US$) in Uganda in 2013?
Keep it short and to the point. 7.08e+09. What is the difference between the Imports (BoP, current US$) in Nicaragua in 2012 and the Imports (BoP, current US$) in Uganda in 2013?
Provide a short and direct response. -8.06e+08. What is the average Imports (BoP, current US$) in Upper middle income per year?
Your answer should be very brief. 3.46e+12. What is the average Imports (BoP, current US$) in Bahrain per year?
Offer a very short reply. 1.36e+1. What is the average Imports (BoP, current US$) in Nicaragua per year?
Your answer should be compact. 5.36e+09. What is the average Imports (BoP, current US$) in Uganda per year?
Keep it short and to the point. 5.80e+09. In the year 2006, what is the difference between the Imports (BoP, current US$) in Upper middle income and Imports (BoP, current US$) in Bahrain?
Your answer should be compact. 2.17e+12. In the year 2006, what is the difference between the Imports (BoP, current US$) of Upper middle income and Imports (BoP, current US$) of Nicaragua?
Offer a very short reply. 2.17e+12. In the year 2006, what is the difference between the Imports (BoP, current US$) of Upper middle income and Imports (BoP, current US$) of Uganda?
Offer a terse response. 2.17e+12. In the year 2006, what is the difference between the Imports (BoP, current US$) in Bahrain and Imports (BoP, current US$) in Nicaragua?
Your response must be concise. 7.88e+09. In the year 2006, what is the difference between the Imports (BoP, current US$) of Bahrain and Imports (BoP, current US$) of Uganda?
Provide a short and direct response. 8.57e+09. In the year 2006, what is the difference between the Imports (BoP, current US$) in Nicaragua and Imports (BoP, current US$) in Uganda?
Your answer should be compact. 6.95e+08. In the year 2007, what is the difference between the Imports (BoP, current US$) of Upper middle income and Imports (BoP, current US$) of Bahrain?
Your answer should be very brief. 2.62e+12. In the year 2007, what is the difference between the Imports (BoP, current US$) in Upper middle income and Imports (BoP, current US$) in Nicaragua?
Offer a terse response. 2.63e+12. In the year 2007, what is the difference between the Imports (BoP, current US$) in Upper middle income and Imports (BoP, current US$) in Uganda?
Offer a terse response. 2.63e+12. In the year 2007, what is the difference between the Imports (BoP, current US$) in Bahrain and Imports (BoP, current US$) in Nicaragua?
Your answer should be compact. 8.18e+09. In the year 2007, what is the difference between the Imports (BoP, current US$) in Bahrain and Imports (BoP, current US$) in Uganda?
Provide a short and direct response. 8.69e+09. In the year 2007, what is the difference between the Imports (BoP, current US$) in Nicaragua and Imports (BoP, current US$) in Uganda?
Offer a terse response. 5.15e+08. In the year 2008, what is the difference between the Imports (BoP, current US$) in Upper middle income and Imports (BoP, current US$) in Bahrain?
Provide a succinct answer. 3.19e+12. In the year 2008, what is the difference between the Imports (BoP, current US$) of Upper middle income and Imports (BoP, current US$) of Nicaragua?
Your answer should be very brief. 3.20e+12. In the year 2008, what is the difference between the Imports (BoP, current US$) of Upper middle income and Imports (BoP, current US$) of Uganda?
Offer a terse response. 3.20e+12. In the year 2008, what is the difference between the Imports (BoP, current US$) of Bahrain and Imports (BoP, current US$) of Nicaragua?
Give a very brief answer. 1.10e+1. In the year 2008, what is the difference between the Imports (BoP, current US$) in Bahrain and Imports (BoP, current US$) in Uganda?
Provide a succinct answer. 1.10e+1. In the year 2008, what is the difference between the Imports (BoP, current US$) in Nicaragua and Imports (BoP, current US$) in Uganda?
Offer a terse response. -4.49e+07. In the year 2009, what is the difference between the Imports (BoP, current US$) of Upper middle income and Imports (BoP, current US$) of Bahrain?
Your response must be concise. 2.66e+12. In the year 2009, what is the difference between the Imports (BoP, current US$) of Upper middle income and Imports (BoP, current US$) of Nicaragua?
Keep it short and to the point. 2.67e+12. In the year 2009, what is the difference between the Imports (BoP, current US$) of Upper middle income and Imports (BoP, current US$) of Uganda?
Your response must be concise. 2.67e+12. In the year 2009, what is the difference between the Imports (BoP, current US$) in Bahrain and Imports (BoP, current US$) in Nicaragua?
Offer a terse response. 6.94e+09. In the year 2009, what is the difference between the Imports (BoP, current US$) in Bahrain and Imports (BoP, current US$) in Uganda?
Your response must be concise. 6.13e+09. In the year 2009, what is the difference between the Imports (BoP, current US$) in Nicaragua and Imports (BoP, current US$) in Uganda?
Offer a very short reply. -8.17e+08. In the year 2010, what is the difference between the Imports (BoP, current US$) of Upper middle income and Imports (BoP, current US$) of Bahrain?
Offer a very short reply. 3.44e+12. In the year 2010, what is the difference between the Imports (BoP, current US$) of Upper middle income and Imports (BoP, current US$) of Nicaragua?
Keep it short and to the point. 3.45e+12. In the year 2010, what is the difference between the Imports (BoP, current US$) of Upper middle income and Imports (BoP, current US$) of Uganda?
Offer a terse response. 3.45e+12. In the year 2010, what is the difference between the Imports (BoP, current US$) in Bahrain and Imports (BoP, current US$) in Nicaragua?
Offer a terse response. 8.03e+09. In the year 2010, what is the difference between the Imports (BoP, current US$) in Bahrain and Imports (BoP, current US$) in Uganda?
Your answer should be very brief. 6.92e+09. In the year 2010, what is the difference between the Imports (BoP, current US$) in Nicaragua and Imports (BoP, current US$) in Uganda?
Your response must be concise. -1.12e+09. In the year 2011, what is the difference between the Imports (BoP, current US$) of Upper middle income and Imports (BoP, current US$) of Bahrain?
Give a very brief answer. 4.23e+12. In the year 2011, what is the difference between the Imports (BoP, current US$) of Upper middle income and Imports (BoP, current US$) of Nicaragua?
Ensure brevity in your answer.  4.24e+12. In the year 2011, what is the difference between the Imports (BoP, current US$) in Upper middle income and Imports (BoP, current US$) in Uganda?
Offer a terse response. 4.24e+12. In the year 2011, what is the difference between the Imports (BoP, current US$) in Bahrain and Imports (BoP, current US$) in Nicaragua?
Make the answer very short. 7.58e+09. In the year 2011, what is the difference between the Imports (BoP, current US$) in Bahrain and Imports (BoP, current US$) in Uganda?
Keep it short and to the point. 6.45e+09. In the year 2011, what is the difference between the Imports (BoP, current US$) in Nicaragua and Imports (BoP, current US$) in Uganda?
Offer a very short reply. -1.13e+09. In the year 2012, what is the difference between the Imports (BoP, current US$) of Upper middle income and Imports (BoP, current US$) of Bahrain?
Offer a terse response. 4.49e+12. In the year 2012, what is the difference between the Imports (BoP, current US$) of Upper middle income and Imports (BoP, current US$) of Nicaragua?
Your response must be concise. 4.50e+12. In the year 2012, what is the difference between the Imports (BoP, current US$) in Upper middle income and Imports (BoP, current US$) in Uganda?
Offer a very short reply. 4.49e+12. In the year 2012, what is the difference between the Imports (BoP, current US$) in Bahrain and Imports (BoP, current US$) in Nicaragua?
Offer a very short reply. 7.88e+09. In the year 2012, what is the difference between the Imports (BoP, current US$) of Bahrain and Imports (BoP, current US$) of Uganda?
Ensure brevity in your answer.  6.98e+09. In the year 2012, what is the difference between the Imports (BoP, current US$) of Nicaragua and Imports (BoP, current US$) of Uganda?
Make the answer very short. -8.99e+08. In the year 2013, what is the difference between the Imports (BoP, current US$) of Upper middle income and Imports (BoP, current US$) of Bahrain?
Keep it short and to the point. 4.75e+12. In the year 2013, what is the difference between the Imports (BoP, current US$) of Upper middle income and Imports (BoP, current US$) of Nicaragua?
Your response must be concise. 4.76e+12. In the year 2013, what is the difference between the Imports (BoP, current US$) of Upper middle income and Imports (BoP, current US$) of Uganda?
Make the answer very short. 4.76e+12. In the year 2013, what is the difference between the Imports (BoP, current US$) in Bahrain and Imports (BoP, current US$) in Nicaragua?
Your answer should be compact. 8.34e+09. In the year 2013, what is the difference between the Imports (BoP, current US$) in Bahrain and Imports (BoP, current US$) in Uganda?
Provide a short and direct response. 7.57e+09. In the year 2013, what is the difference between the Imports (BoP, current US$) of Nicaragua and Imports (BoP, current US$) of Uganda?
Offer a terse response. -7.70e+08. What is the ratio of the Imports (BoP, current US$) of Upper middle income in 2006 to that in 2007?
Your response must be concise. 0.83. What is the ratio of the Imports (BoP, current US$) of Bahrain in 2006 to that in 2007?
Give a very brief answer. 0.92. What is the ratio of the Imports (BoP, current US$) of Nicaragua in 2006 to that in 2007?
Provide a short and direct response. 0.83. What is the ratio of the Imports (BoP, current US$) of Uganda in 2006 to that in 2007?
Offer a terse response. 0.76. What is the ratio of the Imports (BoP, current US$) in Upper middle income in 2006 to that in 2008?
Offer a very short reply. 0.68. What is the ratio of the Imports (BoP, current US$) of Bahrain in 2006 to that in 2008?
Offer a very short reply. 0.71. What is the ratio of the Imports (BoP, current US$) in Nicaragua in 2006 to that in 2008?
Make the answer very short. 0.7. What is the ratio of the Imports (BoP, current US$) in Uganda in 2006 to that in 2008?
Provide a short and direct response. 0.56. What is the ratio of the Imports (BoP, current US$) of Upper middle income in 2006 to that in 2009?
Your answer should be compact. 0.81. What is the ratio of the Imports (BoP, current US$) of Bahrain in 2006 to that in 2009?
Give a very brief answer. 1.02. What is the ratio of the Imports (BoP, current US$) of Nicaragua in 2006 to that in 2009?
Give a very brief answer. 0.83. What is the ratio of the Imports (BoP, current US$) of Uganda in 2006 to that in 2009?
Your response must be concise. 0.57. What is the ratio of the Imports (BoP, current US$) in Upper middle income in 2006 to that in 2010?
Give a very brief answer. 0.63. What is the ratio of the Imports (BoP, current US$) in Bahrain in 2006 to that in 2010?
Your answer should be compact. 0.88. What is the ratio of the Imports (BoP, current US$) of Nicaragua in 2006 to that in 2010?
Offer a very short reply. 0.73. What is the ratio of the Imports (BoP, current US$) in Uganda in 2006 to that in 2010?
Offer a very short reply. 0.48. What is the ratio of the Imports (BoP, current US$) in Upper middle income in 2006 to that in 2011?
Your answer should be compact. 0.51. What is the ratio of the Imports (BoP, current US$) of Bahrain in 2006 to that in 2011?
Provide a short and direct response. 0.83. What is the ratio of the Imports (BoP, current US$) of Nicaragua in 2006 to that in 2011?
Make the answer very short. 0.58. What is the ratio of the Imports (BoP, current US$) of Uganda in 2006 to that in 2011?
Offer a very short reply. 0.4. What is the ratio of the Imports (BoP, current US$) in Upper middle income in 2006 to that in 2012?
Your answer should be very brief. 0.48. What is the ratio of the Imports (BoP, current US$) of Bahrain in 2006 to that in 2012?
Provide a succinct answer. 0.79. What is the ratio of the Imports (BoP, current US$) of Nicaragua in 2006 to that in 2012?
Make the answer very short. 0.54. What is the ratio of the Imports (BoP, current US$) of Uganda in 2006 to that in 2012?
Offer a very short reply. 0.39. What is the ratio of the Imports (BoP, current US$) of Upper middle income in 2006 to that in 2013?
Give a very brief answer. 0.46. What is the ratio of the Imports (BoP, current US$) of Bahrain in 2006 to that in 2013?
Your response must be concise. 0.76. What is the ratio of the Imports (BoP, current US$) in Nicaragua in 2006 to that in 2013?
Ensure brevity in your answer.  0.54. What is the ratio of the Imports (BoP, current US$) of Uganda in 2006 to that in 2013?
Your answer should be compact. 0.39. What is the ratio of the Imports (BoP, current US$) of Upper middle income in 2007 to that in 2008?
Provide a succinct answer. 0.82. What is the ratio of the Imports (BoP, current US$) in Bahrain in 2007 to that in 2008?
Your answer should be very brief. 0.78. What is the ratio of the Imports (BoP, current US$) in Nicaragua in 2007 to that in 2008?
Your answer should be very brief. 0.85. What is the ratio of the Imports (BoP, current US$) in Uganda in 2007 to that in 2008?
Keep it short and to the point. 0.74. What is the ratio of the Imports (BoP, current US$) in Upper middle income in 2007 to that in 2009?
Provide a succinct answer. 0.99. What is the ratio of the Imports (BoP, current US$) of Bahrain in 2007 to that in 2009?
Make the answer very short. 1.11. What is the ratio of the Imports (BoP, current US$) of Uganda in 2007 to that in 2009?
Your answer should be compact. 0.75. What is the ratio of the Imports (BoP, current US$) in Upper middle income in 2007 to that in 2010?
Offer a very short reply. 0.76. What is the ratio of the Imports (BoP, current US$) in Bahrain in 2007 to that in 2010?
Ensure brevity in your answer.  0.96. What is the ratio of the Imports (BoP, current US$) in Nicaragua in 2007 to that in 2010?
Provide a succinct answer. 0.88. What is the ratio of the Imports (BoP, current US$) of Uganda in 2007 to that in 2010?
Your answer should be compact. 0.64. What is the ratio of the Imports (BoP, current US$) of Upper middle income in 2007 to that in 2011?
Your response must be concise. 0.62. What is the ratio of the Imports (BoP, current US$) of Bahrain in 2007 to that in 2011?
Provide a short and direct response. 0.91. What is the ratio of the Imports (BoP, current US$) of Nicaragua in 2007 to that in 2011?
Give a very brief answer. 0.71. What is the ratio of the Imports (BoP, current US$) of Uganda in 2007 to that in 2011?
Give a very brief answer. 0.53. What is the ratio of the Imports (BoP, current US$) of Upper middle income in 2007 to that in 2012?
Your answer should be very brief. 0.59. What is the ratio of the Imports (BoP, current US$) in Bahrain in 2007 to that in 2012?
Offer a terse response. 0.86. What is the ratio of the Imports (BoP, current US$) of Nicaragua in 2007 to that in 2012?
Offer a terse response. 0.65. What is the ratio of the Imports (BoP, current US$) of Uganda in 2007 to that in 2012?
Your answer should be very brief. 0.51. What is the ratio of the Imports (BoP, current US$) of Upper middle income in 2007 to that in 2013?
Provide a succinct answer. 0.55. What is the ratio of the Imports (BoP, current US$) in Bahrain in 2007 to that in 2013?
Ensure brevity in your answer.  0.83. What is the ratio of the Imports (BoP, current US$) in Nicaragua in 2007 to that in 2013?
Your answer should be very brief. 0.65. What is the ratio of the Imports (BoP, current US$) in Uganda in 2007 to that in 2013?
Offer a very short reply. 0.51. What is the ratio of the Imports (BoP, current US$) of Upper middle income in 2008 to that in 2009?
Offer a terse response. 1.2. What is the ratio of the Imports (BoP, current US$) of Bahrain in 2008 to that in 2009?
Your answer should be compact. 1.43. What is the ratio of the Imports (BoP, current US$) in Nicaragua in 2008 to that in 2009?
Offer a terse response. 1.19. What is the ratio of the Imports (BoP, current US$) of Uganda in 2008 to that in 2009?
Your answer should be very brief. 1.01. What is the ratio of the Imports (BoP, current US$) in Upper middle income in 2008 to that in 2010?
Your response must be concise. 0.93. What is the ratio of the Imports (BoP, current US$) in Bahrain in 2008 to that in 2010?
Your answer should be very brief. 1.24. What is the ratio of the Imports (BoP, current US$) of Nicaragua in 2008 to that in 2010?
Provide a succinct answer. 1.04. What is the ratio of the Imports (BoP, current US$) in Uganda in 2008 to that in 2010?
Offer a very short reply. 0.86. What is the ratio of the Imports (BoP, current US$) of Upper middle income in 2008 to that in 2011?
Ensure brevity in your answer.  0.75. What is the ratio of the Imports (BoP, current US$) of Bahrain in 2008 to that in 2011?
Provide a short and direct response. 1.17. What is the ratio of the Imports (BoP, current US$) in Nicaragua in 2008 to that in 2011?
Keep it short and to the point. 0.83. What is the ratio of the Imports (BoP, current US$) of Uganda in 2008 to that in 2011?
Make the answer very short. 0.71. What is the ratio of the Imports (BoP, current US$) of Upper middle income in 2008 to that in 2012?
Make the answer very short. 0.71. What is the ratio of the Imports (BoP, current US$) in Bahrain in 2008 to that in 2012?
Offer a very short reply. 1.11. What is the ratio of the Imports (BoP, current US$) in Nicaragua in 2008 to that in 2012?
Offer a very short reply. 0.77. What is the ratio of the Imports (BoP, current US$) of Uganda in 2008 to that in 2012?
Give a very brief answer. 0.69. What is the ratio of the Imports (BoP, current US$) of Upper middle income in 2008 to that in 2013?
Provide a short and direct response. 0.67. What is the ratio of the Imports (BoP, current US$) of Bahrain in 2008 to that in 2013?
Your answer should be very brief. 1.07. What is the ratio of the Imports (BoP, current US$) in Nicaragua in 2008 to that in 2013?
Provide a succinct answer. 0.76. What is the ratio of the Imports (BoP, current US$) in Uganda in 2008 to that in 2013?
Offer a terse response. 0.69. What is the ratio of the Imports (BoP, current US$) of Upper middle income in 2009 to that in 2010?
Your response must be concise. 0.77. What is the ratio of the Imports (BoP, current US$) in Bahrain in 2009 to that in 2010?
Give a very brief answer. 0.87. What is the ratio of the Imports (BoP, current US$) in Nicaragua in 2009 to that in 2010?
Ensure brevity in your answer.  0.87. What is the ratio of the Imports (BoP, current US$) of Uganda in 2009 to that in 2010?
Provide a short and direct response. 0.85. What is the ratio of the Imports (BoP, current US$) in Upper middle income in 2009 to that in 2011?
Your answer should be very brief. 0.63. What is the ratio of the Imports (BoP, current US$) of Bahrain in 2009 to that in 2011?
Ensure brevity in your answer.  0.82. What is the ratio of the Imports (BoP, current US$) in Nicaragua in 2009 to that in 2011?
Keep it short and to the point. 0.7. What is the ratio of the Imports (BoP, current US$) of Uganda in 2009 to that in 2011?
Offer a very short reply. 0.7. What is the ratio of the Imports (BoP, current US$) in Upper middle income in 2009 to that in 2012?
Your response must be concise. 0.59. What is the ratio of the Imports (BoP, current US$) in Bahrain in 2009 to that in 2012?
Offer a terse response. 0.77. What is the ratio of the Imports (BoP, current US$) in Nicaragua in 2009 to that in 2012?
Give a very brief answer. 0.65. What is the ratio of the Imports (BoP, current US$) of Uganda in 2009 to that in 2012?
Offer a terse response. 0.68. What is the ratio of the Imports (BoP, current US$) of Upper middle income in 2009 to that in 2013?
Provide a succinct answer. 0.56. What is the ratio of the Imports (BoP, current US$) in Bahrain in 2009 to that in 2013?
Make the answer very short. 0.75. What is the ratio of the Imports (BoP, current US$) of Nicaragua in 2009 to that in 2013?
Provide a succinct answer. 0.64. What is the ratio of the Imports (BoP, current US$) of Uganda in 2009 to that in 2013?
Offer a terse response. 0.68. What is the ratio of the Imports (BoP, current US$) of Upper middle income in 2010 to that in 2011?
Provide a succinct answer. 0.81. What is the ratio of the Imports (BoP, current US$) in Bahrain in 2010 to that in 2011?
Keep it short and to the point. 0.94. What is the ratio of the Imports (BoP, current US$) of Nicaragua in 2010 to that in 2011?
Give a very brief answer. 0.8. What is the ratio of the Imports (BoP, current US$) of Uganda in 2010 to that in 2011?
Provide a succinct answer. 0.83. What is the ratio of the Imports (BoP, current US$) of Upper middle income in 2010 to that in 2012?
Offer a very short reply. 0.77. What is the ratio of the Imports (BoP, current US$) of Bahrain in 2010 to that in 2012?
Ensure brevity in your answer.  0.89. What is the ratio of the Imports (BoP, current US$) of Nicaragua in 2010 to that in 2012?
Give a very brief answer. 0.74. What is the ratio of the Imports (BoP, current US$) in Uganda in 2010 to that in 2012?
Your answer should be very brief. 0.8. What is the ratio of the Imports (BoP, current US$) in Upper middle income in 2010 to that in 2013?
Make the answer very short. 0.72. What is the ratio of the Imports (BoP, current US$) of Bahrain in 2010 to that in 2013?
Offer a very short reply. 0.86. What is the ratio of the Imports (BoP, current US$) of Nicaragua in 2010 to that in 2013?
Provide a succinct answer. 0.74. What is the ratio of the Imports (BoP, current US$) in Uganda in 2010 to that in 2013?
Offer a very short reply. 0.81. What is the ratio of the Imports (BoP, current US$) in Upper middle income in 2011 to that in 2012?
Your answer should be compact. 0.94. What is the ratio of the Imports (BoP, current US$) of Bahrain in 2011 to that in 2012?
Your answer should be very brief. 0.94. What is the ratio of the Imports (BoP, current US$) of Nicaragua in 2011 to that in 2012?
Your response must be concise. 0.92. What is the ratio of the Imports (BoP, current US$) of Uganda in 2011 to that in 2012?
Your answer should be compact. 0.96. What is the ratio of the Imports (BoP, current US$) of Upper middle income in 2011 to that in 2013?
Your answer should be very brief. 0.89. What is the ratio of the Imports (BoP, current US$) in Bahrain in 2011 to that in 2013?
Offer a very short reply. 0.91. What is the ratio of the Imports (BoP, current US$) in Nicaragua in 2011 to that in 2013?
Provide a succinct answer. 0.92. What is the ratio of the Imports (BoP, current US$) in Uganda in 2011 to that in 2013?
Ensure brevity in your answer.  0.97. What is the ratio of the Imports (BoP, current US$) in Upper middle income in 2012 to that in 2013?
Provide a short and direct response. 0.94. What is the ratio of the Imports (BoP, current US$) of Bahrain in 2012 to that in 2013?
Provide a short and direct response. 0.97. What is the ratio of the Imports (BoP, current US$) of Nicaragua in 2012 to that in 2013?
Provide a short and direct response. 0.99. What is the ratio of the Imports (BoP, current US$) of Uganda in 2012 to that in 2013?
Ensure brevity in your answer.  1.01. What is the difference between the highest and the second highest Imports (BoP, current US$) in Upper middle income?
Provide a short and direct response. 2.68e+11. What is the difference between the highest and the second highest Imports (BoP, current US$) of Bahrain?
Your response must be concise. 1.06e+09. What is the difference between the highest and the second highest Imports (BoP, current US$) of Nicaragua?
Make the answer very short. 3.58e+07. What is the difference between the highest and the second highest Imports (BoP, current US$) of Uganda?
Ensure brevity in your answer.  9.31e+07. What is the difference between the highest and the lowest Imports (BoP, current US$) in Upper middle income?
Your answer should be very brief. 2.59e+12. What is the difference between the highest and the lowest Imports (BoP, current US$) of Bahrain?
Your answer should be compact. 4.92e+09. What is the difference between the highest and the lowest Imports (BoP, current US$) of Nicaragua?
Offer a very short reply. 3.19e+09. What is the difference between the highest and the lowest Imports (BoP, current US$) of Uganda?
Offer a very short reply. 4.75e+09. 